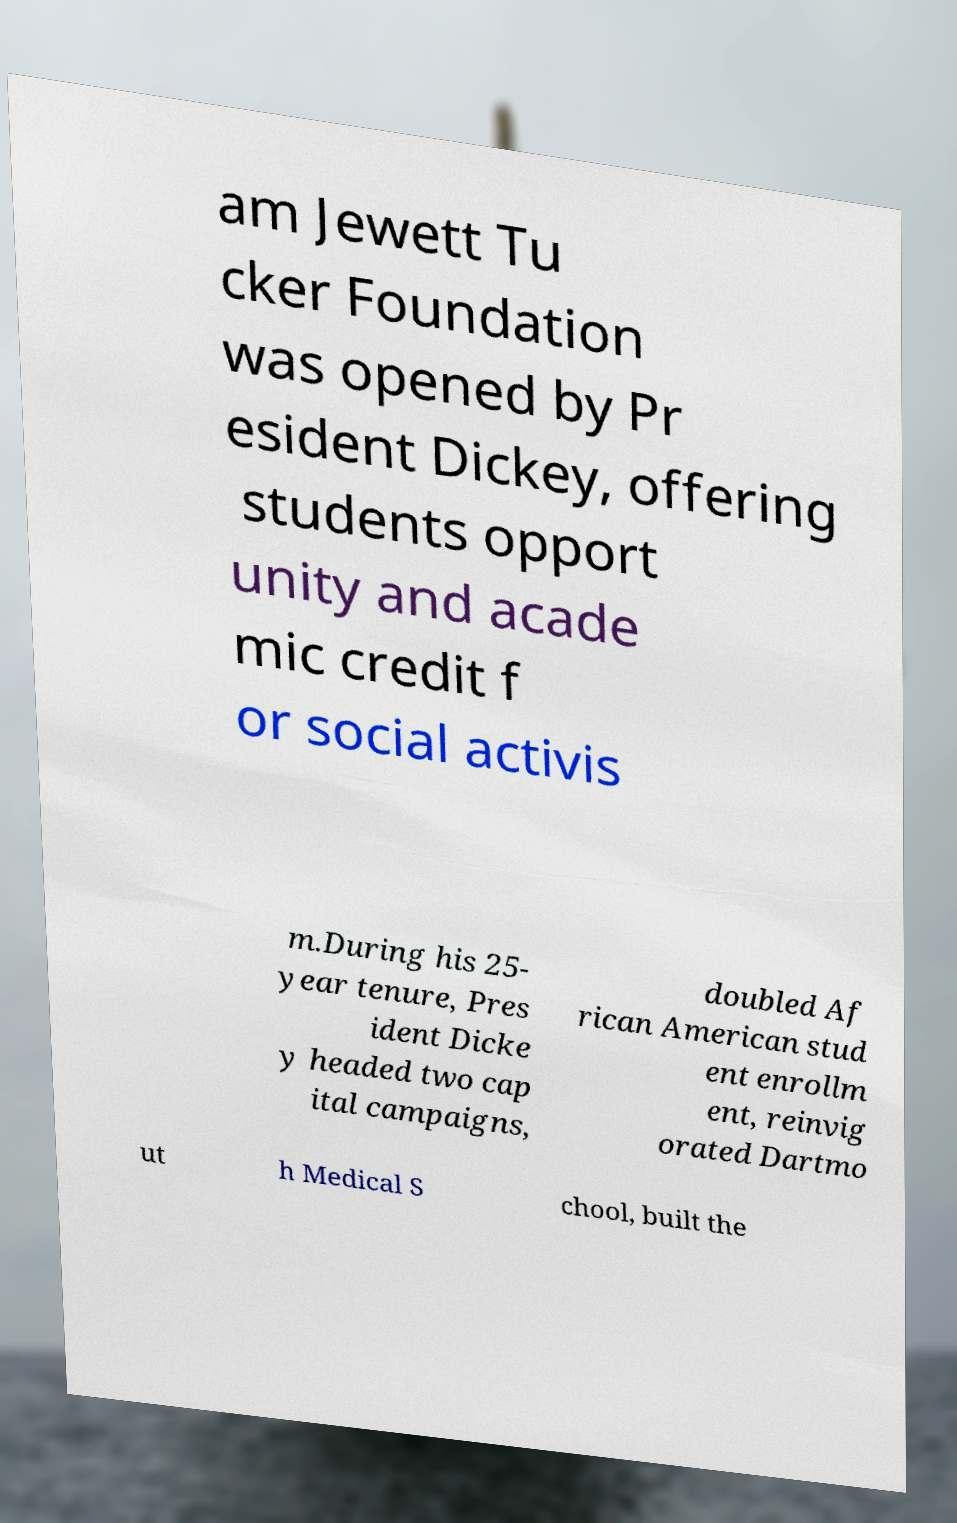Can you accurately transcribe the text from the provided image for me? am Jewett Tu cker Foundation was opened by Pr esident Dickey, offering students opport unity and acade mic credit f or social activis m.During his 25- year tenure, Pres ident Dicke y headed two cap ital campaigns, doubled Af rican American stud ent enrollm ent, reinvig orated Dartmo ut h Medical S chool, built the 